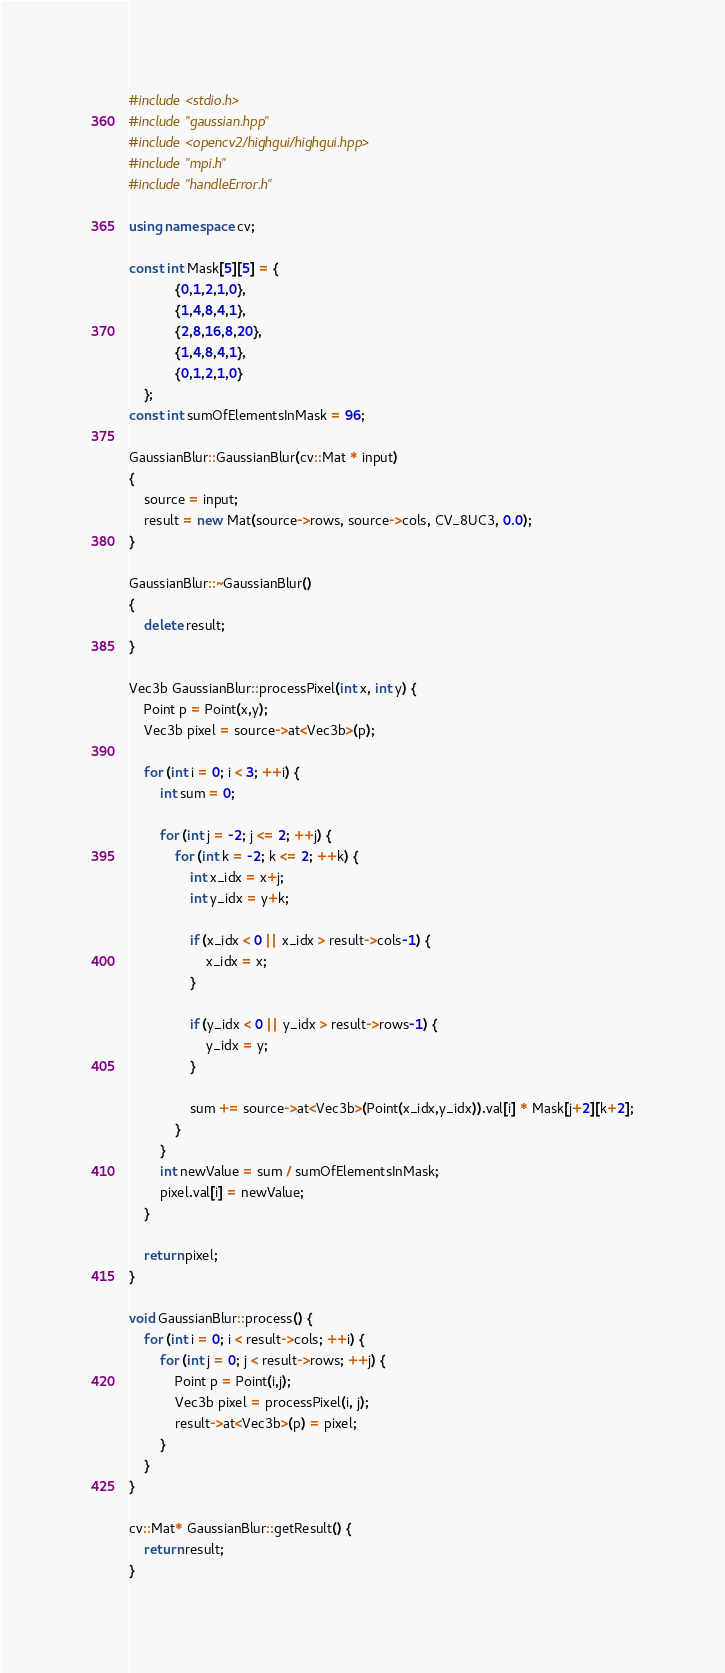<code> <loc_0><loc_0><loc_500><loc_500><_C++_>#include <stdio.h>
#include "gaussian.hpp"
#include <opencv2/highgui/highgui.hpp>
#include "mpi.h"
#include "handleError.h"

using namespace cv;

const int Mask[5][5] = {
            {0,1,2,1,0},
            {1,4,8,4,1},
            {2,8,16,8,20},
            {1,4,8,4,1},
            {0,1,2,1,0}
    };
const int sumOfElementsInMask = 96;

GaussianBlur::GaussianBlur(cv::Mat * input)
{
    source = input;
    result = new Mat(source->rows, source->cols, CV_8UC3, 0.0);
}

GaussianBlur::~GaussianBlur()
{
    delete result;
}

Vec3b GaussianBlur::processPixel(int x, int y) {
    Point p = Point(x,y);
    Vec3b pixel = source->at<Vec3b>(p);

    for (int i = 0; i < 3; ++i) {
        int sum = 0;

        for (int j = -2; j <= 2; ++j) {
            for (int k = -2; k <= 2; ++k) {
                int x_idx = x+j;
                int y_idx = y+k;

                if (x_idx < 0 || x_idx > result->cols-1) {
                    x_idx = x;
                }

                if (y_idx < 0 || y_idx > result->rows-1) {
                    y_idx = y;
                }

                sum += source->at<Vec3b>(Point(x_idx,y_idx)).val[i] * Mask[j+2][k+2];
            }
        }
        int newValue = sum / sumOfElementsInMask;
        pixel.val[i] = newValue;
    }

    return pixel;
}

void GaussianBlur::process() {
    for (int i = 0; i < result->cols; ++i) {
        for (int j = 0; j < result->rows; ++j) {
            Point p = Point(i,j);
            Vec3b pixel = processPixel(i, j);
            result->at<Vec3b>(p) = pixel;
        }
    }
}

cv::Mat* GaussianBlur::getResult() {
    return result;
}</code> 